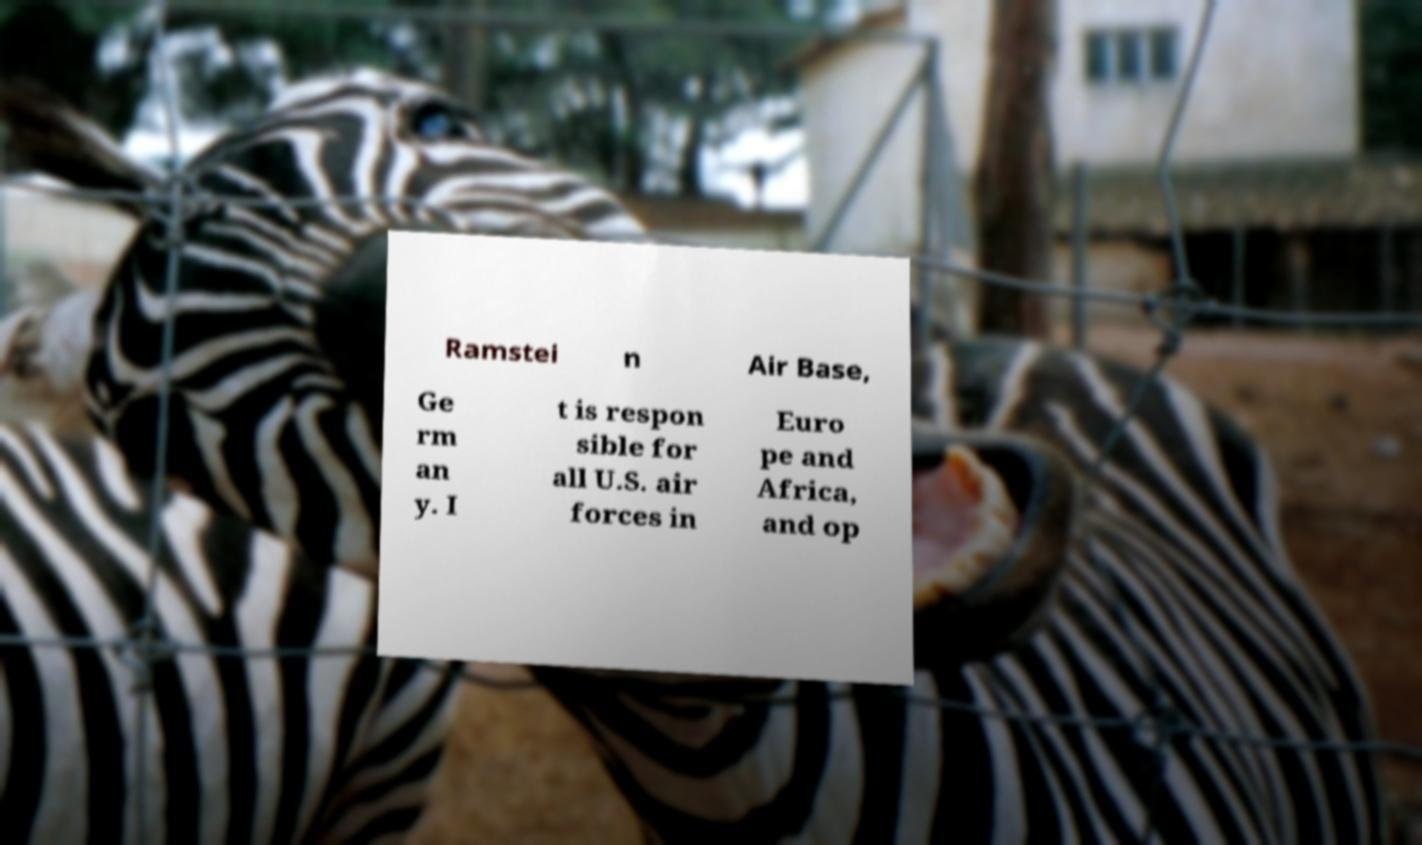Could you assist in decoding the text presented in this image and type it out clearly? Ramstei n Air Base, Ge rm an y. I t is respon sible for all U.S. air forces in Euro pe and Africa, and op 